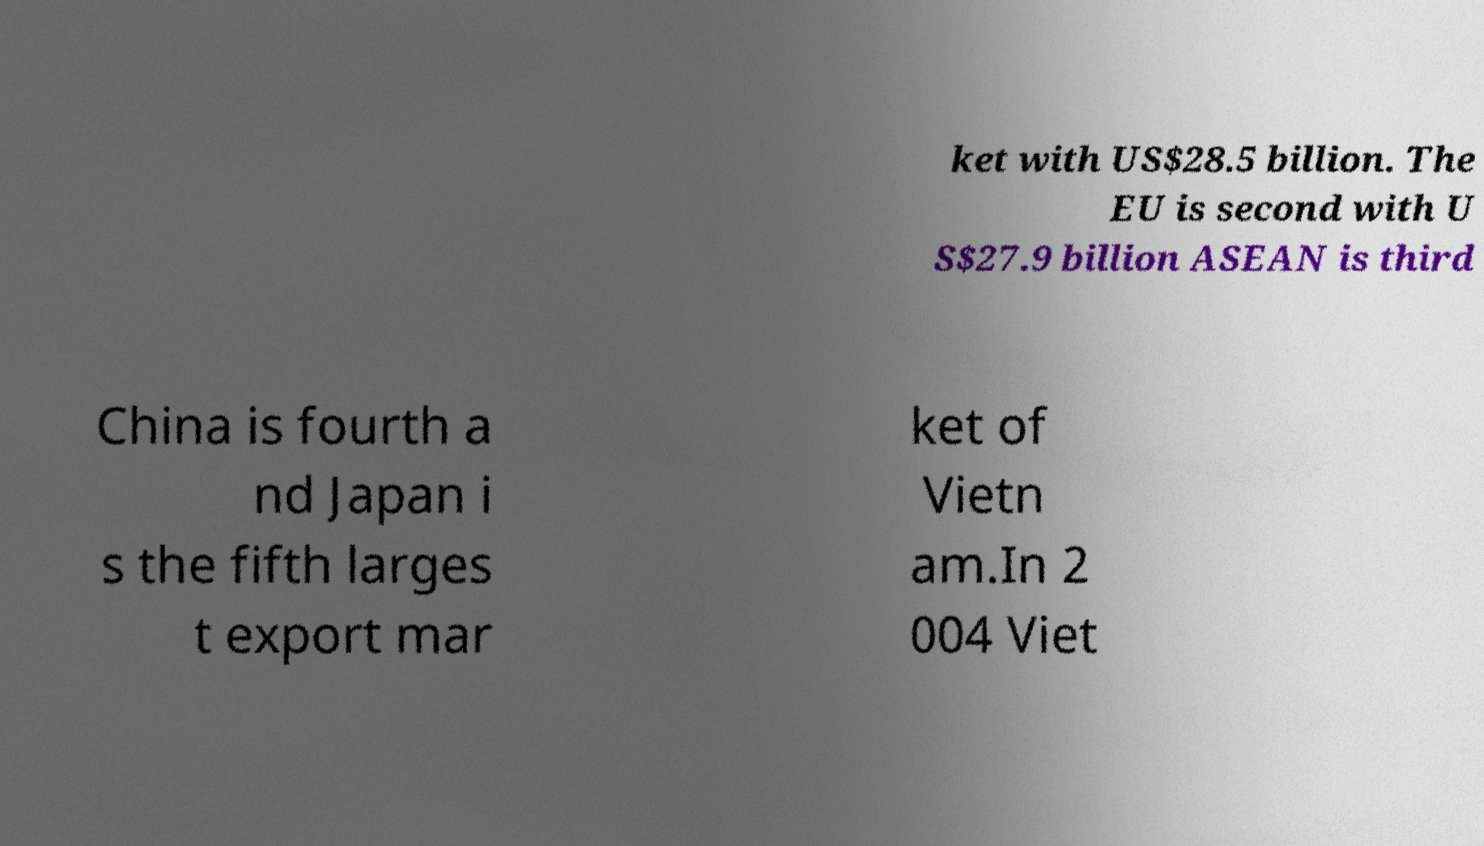There's text embedded in this image that I need extracted. Can you transcribe it verbatim? ket with US$28.5 billion. The EU is second with U S$27.9 billion ASEAN is third China is fourth a nd Japan i s the fifth larges t export mar ket of Vietn am.In 2 004 Viet 